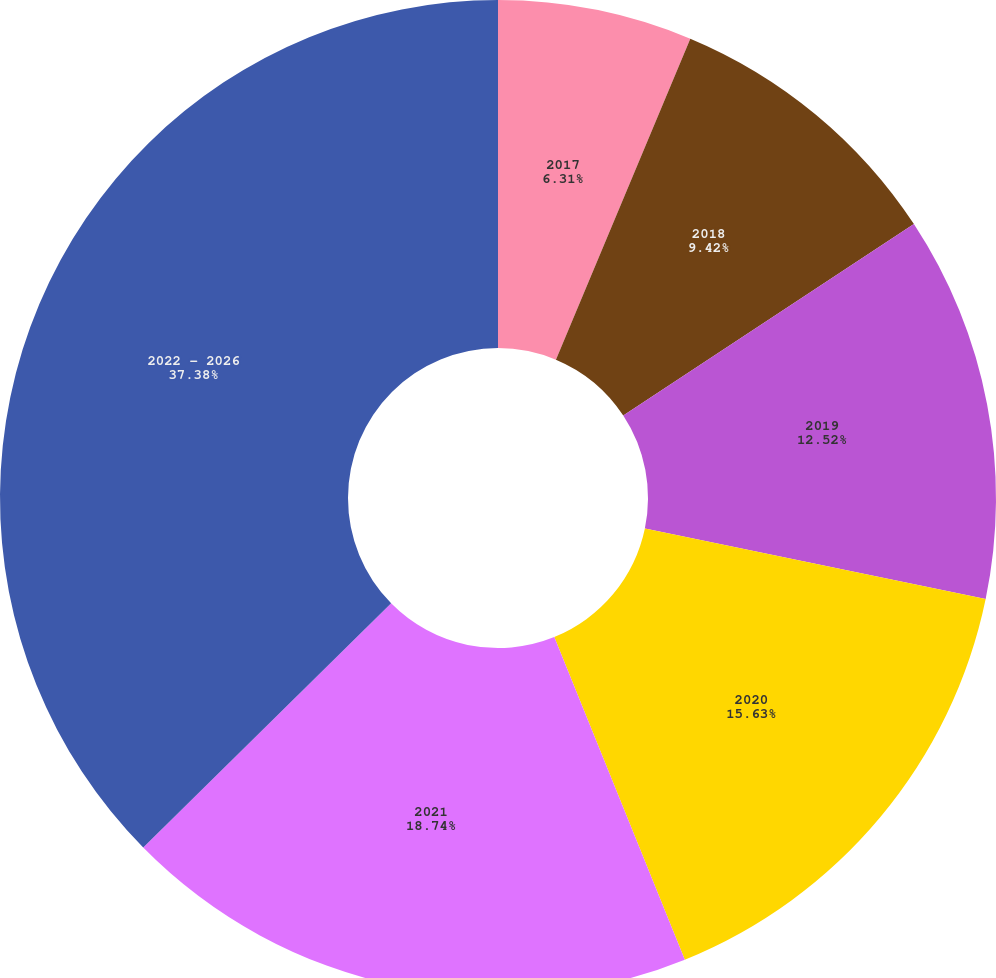<chart> <loc_0><loc_0><loc_500><loc_500><pie_chart><fcel>2017<fcel>2018<fcel>2019<fcel>2020<fcel>2021<fcel>2022 - 2026<nl><fcel>6.31%<fcel>9.42%<fcel>12.52%<fcel>15.63%<fcel>18.74%<fcel>37.38%<nl></chart> 